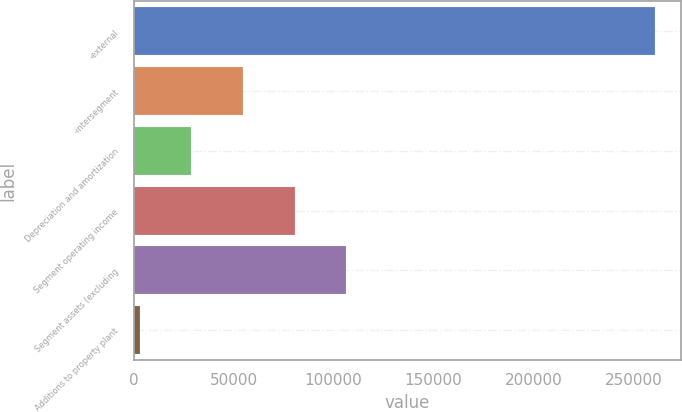Convert chart to OTSL. <chart><loc_0><loc_0><loc_500><loc_500><bar_chart><fcel>-external<fcel>-intersegment<fcel>Depreciation and amortization<fcel>Segment operating income<fcel>Segment assets (excluding<fcel>Additions to property plant<nl><fcel>260982<fcel>54728.4<fcel>28946.7<fcel>80510.1<fcel>106292<fcel>3165<nl></chart> 